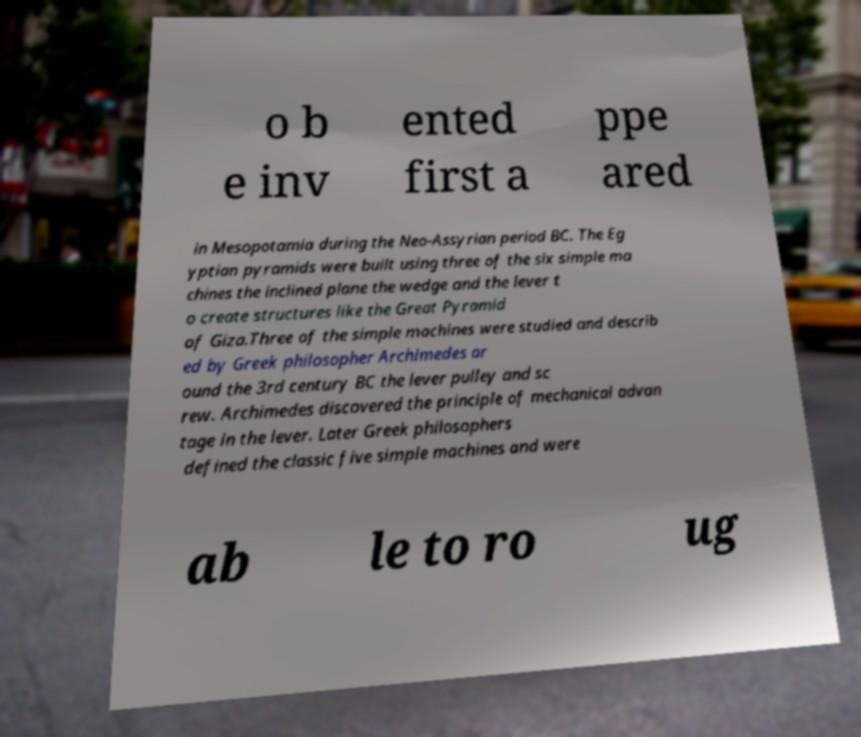I need the written content from this picture converted into text. Can you do that? o b e inv ented first a ppe ared in Mesopotamia during the Neo-Assyrian period BC. The Eg yptian pyramids were built using three of the six simple ma chines the inclined plane the wedge and the lever t o create structures like the Great Pyramid of Giza.Three of the simple machines were studied and describ ed by Greek philosopher Archimedes ar ound the 3rd century BC the lever pulley and sc rew. Archimedes discovered the principle of mechanical advan tage in the lever. Later Greek philosophers defined the classic five simple machines and were ab le to ro ug 